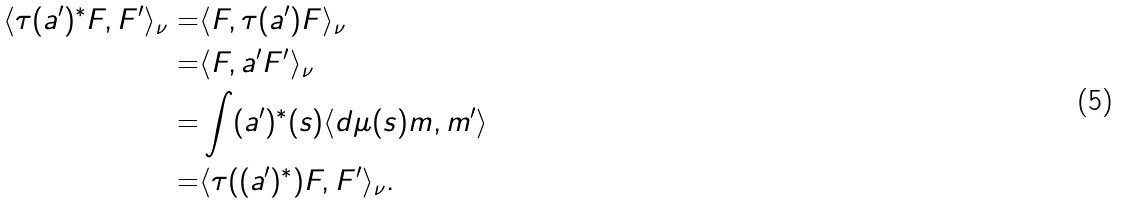Convert formula to latex. <formula><loc_0><loc_0><loc_500><loc_500>\langle \tau ( a ^ { \prime } ) ^ { * } F , F ^ { \prime } \rangle _ { \nu } = & \langle F , \tau ( a ^ { \prime } ) F \rangle _ { \nu } \\ = & \langle F , a ^ { \prime } F ^ { \prime } \rangle _ { \nu } \\ = & \int ( a ^ { \prime } ) ^ { * } ( s ) \langle d \mu ( s ) m , m ^ { \prime } \rangle \\ = & \langle \tau ( ( a ^ { \prime } ) ^ { * } ) F , F ^ { \prime } \rangle _ { \nu } .</formula> 